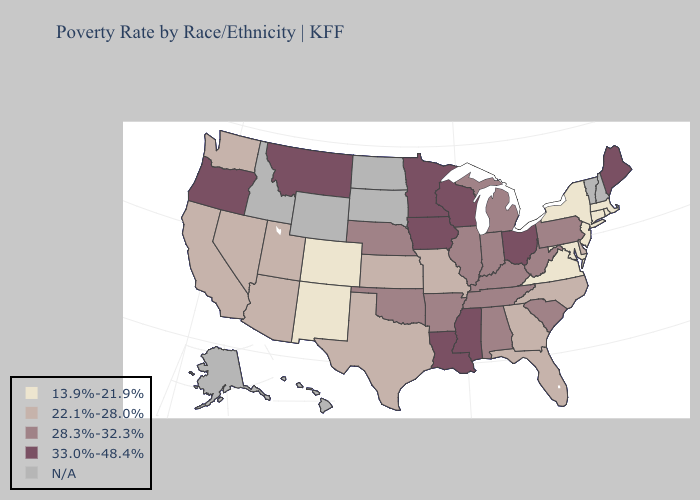Name the states that have a value in the range N/A?
Answer briefly. Alaska, Hawaii, Idaho, New Hampshire, North Dakota, South Dakota, Vermont, Wyoming. Does the map have missing data?
Answer briefly. Yes. Name the states that have a value in the range N/A?
Quick response, please. Alaska, Hawaii, Idaho, New Hampshire, North Dakota, South Dakota, Vermont, Wyoming. What is the value of Minnesota?
Be succinct. 33.0%-48.4%. Among the states that border West Virginia , which have the lowest value?
Be succinct. Maryland, Virginia. Name the states that have a value in the range 22.1%-28.0%?
Give a very brief answer. Arizona, California, Delaware, Florida, Georgia, Kansas, Missouri, Nevada, North Carolina, Texas, Utah, Washington. Among the states that border Alabama , does Florida have the highest value?
Concise answer only. No. What is the value of Iowa?
Concise answer only. 33.0%-48.4%. What is the value of Arkansas?
Concise answer only. 28.3%-32.3%. Name the states that have a value in the range 22.1%-28.0%?
Short answer required. Arizona, California, Delaware, Florida, Georgia, Kansas, Missouri, Nevada, North Carolina, Texas, Utah, Washington. What is the value of Kansas?
Be succinct. 22.1%-28.0%. How many symbols are there in the legend?
Be succinct. 5. Name the states that have a value in the range N/A?
Give a very brief answer. Alaska, Hawaii, Idaho, New Hampshire, North Dakota, South Dakota, Vermont, Wyoming. Among the states that border Minnesota , which have the lowest value?
Be succinct. Iowa, Wisconsin. 